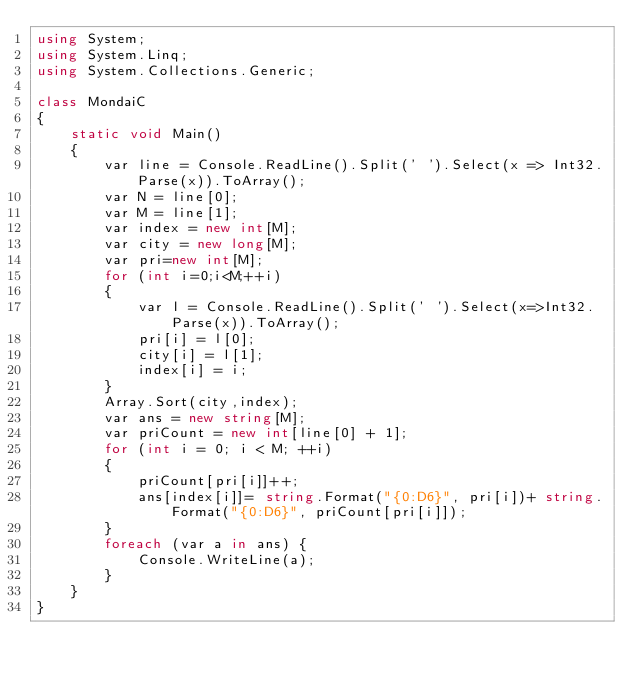<code> <loc_0><loc_0><loc_500><loc_500><_C#_>using System;
using System.Linq;
using System.Collections.Generic;

class MondaiC
{
    static void Main()
    {
        var line = Console.ReadLine().Split(' ').Select(x => Int32.Parse(x)).ToArray();
        var N = line[0];
        var M = line[1];
        var index = new int[M];
        var city = new long[M];
        var pri=new int[M];
        for (int i=0;i<M;++i)
        {
            var l = Console.ReadLine().Split(' ').Select(x=>Int32.Parse(x)).ToArray();
            pri[i] = l[0];
            city[i] = l[1];
            index[i] = i;
        }
        Array.Sort(city,index);
        var ans = new string[M];
        var priCount = new int[line[0] + 1];
        for (int i = 0; i < M; ++i)
        {
            priCount[pri[i]]++;
            ans[index[i]]= string.Format("{0:D6}", pri[i])+ string.Format("{0:D6}", priCount[pri[i]]);
        }
        foreach (var a in ans) {
            Console.WriteLine(a);
        }
    }
}</code> 